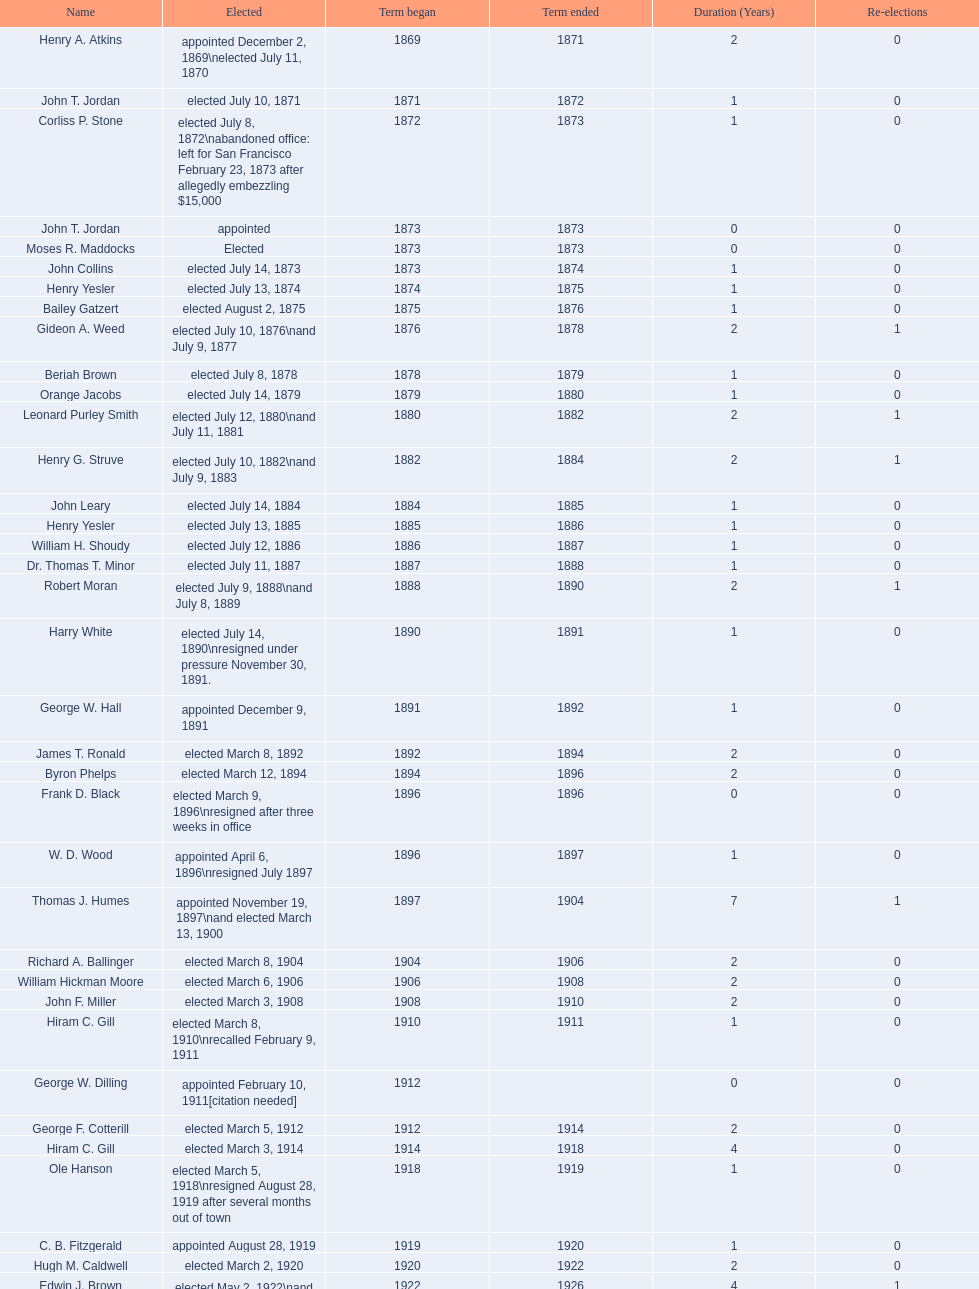How many days did robert moran serve? 365. 